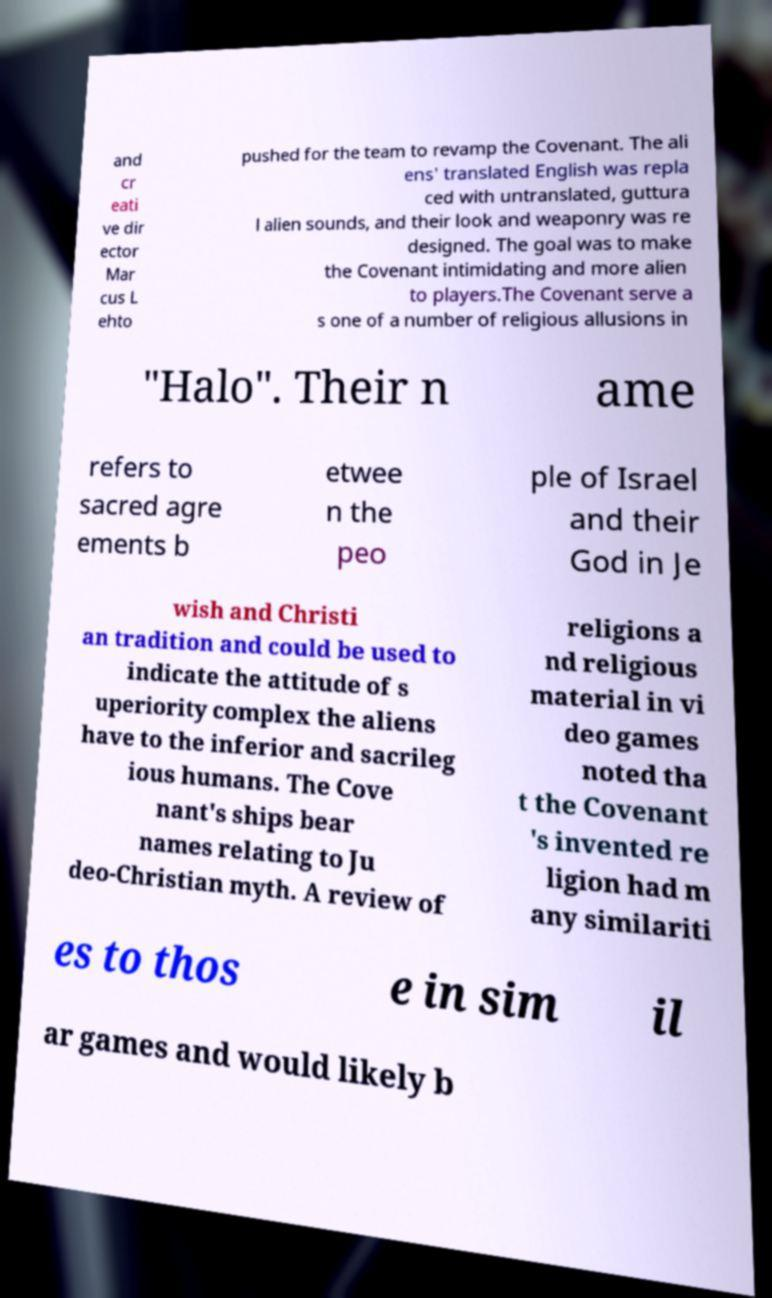I need the written content from this picture converted into text. Can you do that? and cr eati ve dir ector Mar cus L ehto pushed for the team to revamp the Covenant. The ali ens' translated English was repla ced with untranslated, guttura l alien sounds, and their look and weaponry was re designed. The goal was to make the Covenant intimidating and more alien to players.The Covenant serve a s one of a number of religious allusions in "Halo". Their n ame refers to sacred agre ements b etwee n the peo ple of Israel and their God in Je wish and Christi an tradition and could be used to indicate the attitude of s uperiority complex the aliens have to the inferior and sacrileg ious humans. The Cove nant's ships bear names relating to Ju deo-Christian myth. A review of religions a nd religious material in vi deo games noted tha t the Covenant 's invented re ligion had m any similariti es to thos e in sim il ar games and would likely b 